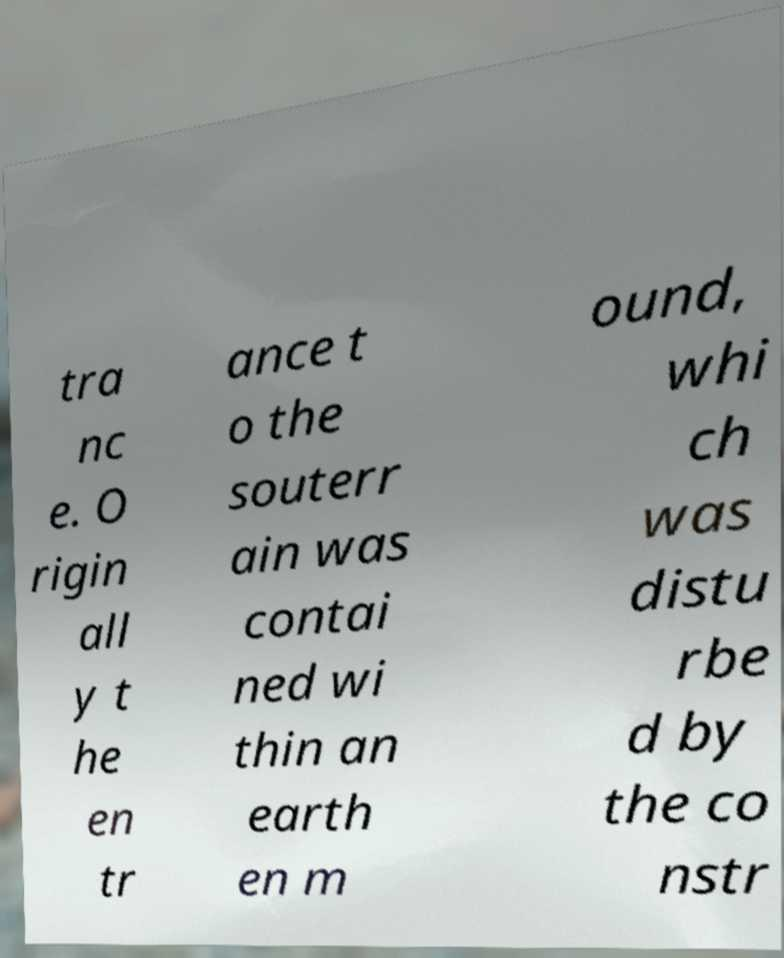Could you extract and type out the text from this image? tra nc e. O rigin all y t he en tr ance t o the souterr ain was contai ned wi thin an earth en m ound, whi ch was distu rbe d by the co nstr 